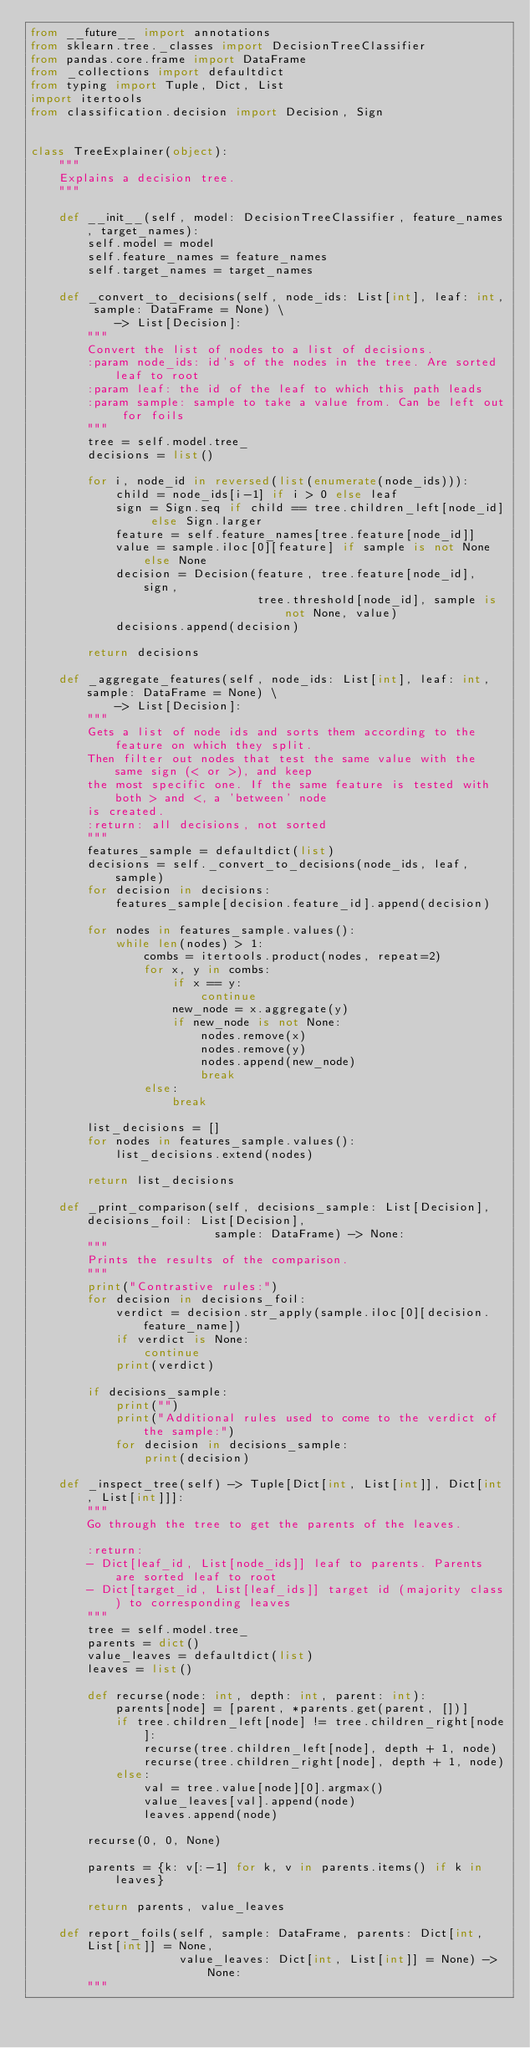<code> <loc_0><loc_0><loc_500><loc_500><_Python_>from __future__ import annotations
from sklearn.tree._classes import DecisionTreeClassifier
from pandas.core.frame import DataFrame
from _collections import defaultdict
from typing import Tuple, Dict, List
import itertools
from classification.decision import Decision, Sign


class TreeExplainer(object):
    """
    Explains a decision tree.
    """

    def __init__(self, model: DecisionTreeClassifier, feature_names, target_names):
        self.model = model
        self.feature_names = feature_names
        self.target_names = target_names

    def _convert_to_decisions(self, node_ids: List[int], leaf: int, sample: DataFrame = None) \
            -> List[Decision]:
        """
        Convert the list of nodes to a list of decisions.
        :param node_ids: id's of the nodes in the tree. Are sorted leaf to root
        :param leaf: the id of the leaf to which this path leads
        :param sample: sample to take a value from. Can be left out for foils
        """
        tree = self.model.tree_
        decisions = list()

        for i, node_id in reversed(list(enumerate(node_ids))):
            child = node_ids[i-1] if i > 0 else leaf
            sign = Sign.seq if child == tree.children_left[node_id] else Sign.larger
            feature = self.feature_names[tree.feature[node_id]]
            value = sample.iloc[0][feature] if sample is not None else None
            decision = Decision(feature, tree.feature[node_id], sign,
                                tree.threshold[node_id], sample is not None, value)
            decisions.append(decision)

        return decisions

    def _aggregate_features(self, node_ids: List[int], leaf: int, sample: DataFrame = None) \
            -> List[Decision]:
        """
        Gets a list of node ids and sorts them according to the feature on which they split.
        Then filter out nodes that test the same value with the same sign (< or >), and keep
        the most specific one. If the same feature is tested with both > and <, a 'between' node
        is created.
        :return: all decisions, not sorted
        """
        features_sample = defaultdict(list)
        decisions = self._convert_to_decisions(node_ids, leaf, sample)
        for decision in decisions:
            features_sample[decision.feature_id].append(decision)

        for nodes in features_sample.values():
            while len(nodes) > 1:
                combs = itertools.product(nodes, repeat=2)
                for x, y in combs:
                    if x == y:
                        continue
                    new_node = x.aggregate(y)
                    if new_node is not None:
                        nodes.remove(x)
                        nodes.remove(y)
                        nodes.append(new_node)
                        break
                else:
                    break

        list_decisions = []
        for nodes in features_sample.values():
            list_decisions.extend(nodes)

        return list_decisions

    def _print_comparison(self, decisions_sample: List[Decision], decisions_foil: List[Decision],
                          sample: DataFrame) -> None:
        """
        Prints the results of the comparison.
        """
        print("Contrastive rules:")
        for decision in decisions_foil:
            verdict = decision.str_apply(sample.iloc[0][decision.feature_name])
            if verdict is None:
                continue
            print(verdict)

        if decisions_sample:
            print("")
            print("Additional rules used to come to the verdict of the sample:")
            for decision in decisions_sample:
                print(decision)

    def _inspect_tree(self) -> Tuple[Dict[int, List[int]], Dict[int, List[int]]]:
        """
        Go through the tree to get the parents of the leaves.

        :return:
        - Dict[leaf_id, List[node_ids]] leaf to parents. Parents are sorted leaf to root
        - Dict[target_id, List[leaf_ids]] target id (majority class) to corresponding leaves
        """
        tree = self.model.tree_
        parents = dict()
        value_leaves = defaultdict(list)
        leaves = list()

        def recurse(node: int, depth: int, parent: int):
            parents[node] = [parent, *parents.get(parent, [])]
            if tree.children_left[node] != tree.children_right[node]:
                recurse(tree.children_left[node], depth + 1, node)
                recurse(tree.children_right[node], depth + 1, node)
            else:
                val = tree.value[node][0].argmax()
                value_leaves[val].append(node)
                leaves.append(node)

        recurse(0, 0, None)

        parents = {k: v[:-1] for k, v in parents.items() if k in leaves}

        return parents, value_leaves

    def report_foils(self, sample: DataFrame, parents: Dict[int, List[int]] = None,
                     value_leaves: Dict[int, List[int]] = None) -> None:
        """</code> 